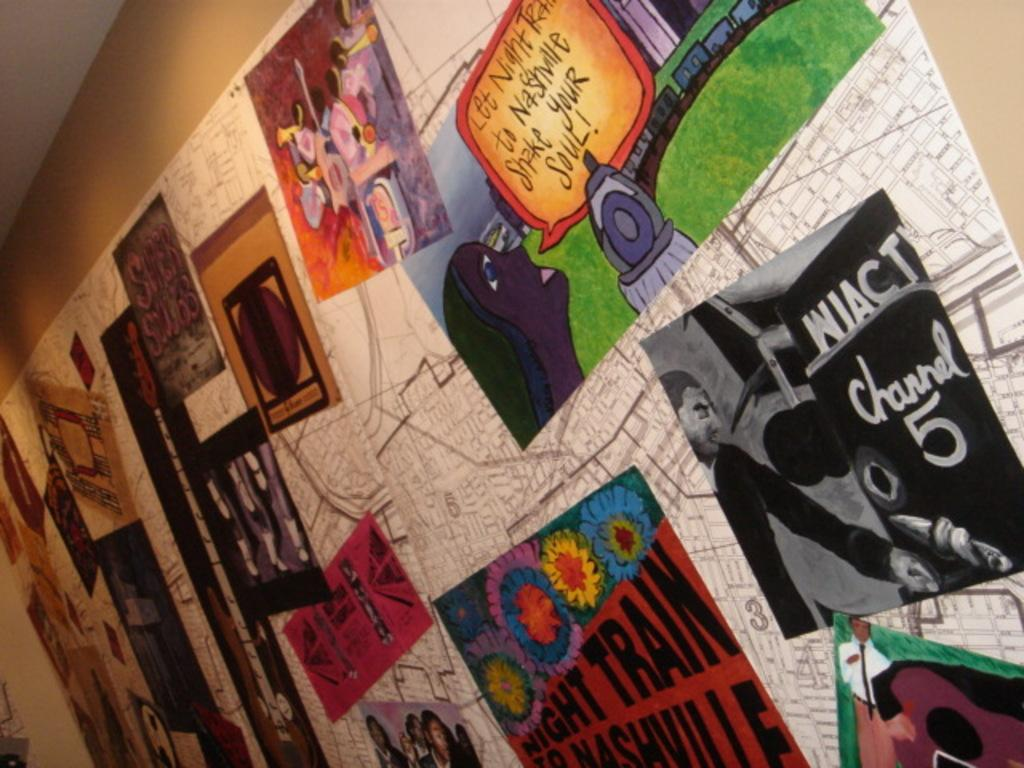<image>
Give a short and clear explanation of the subsequent image. Bulletin Board with posters Black and white photo with Wiact Channel 5 